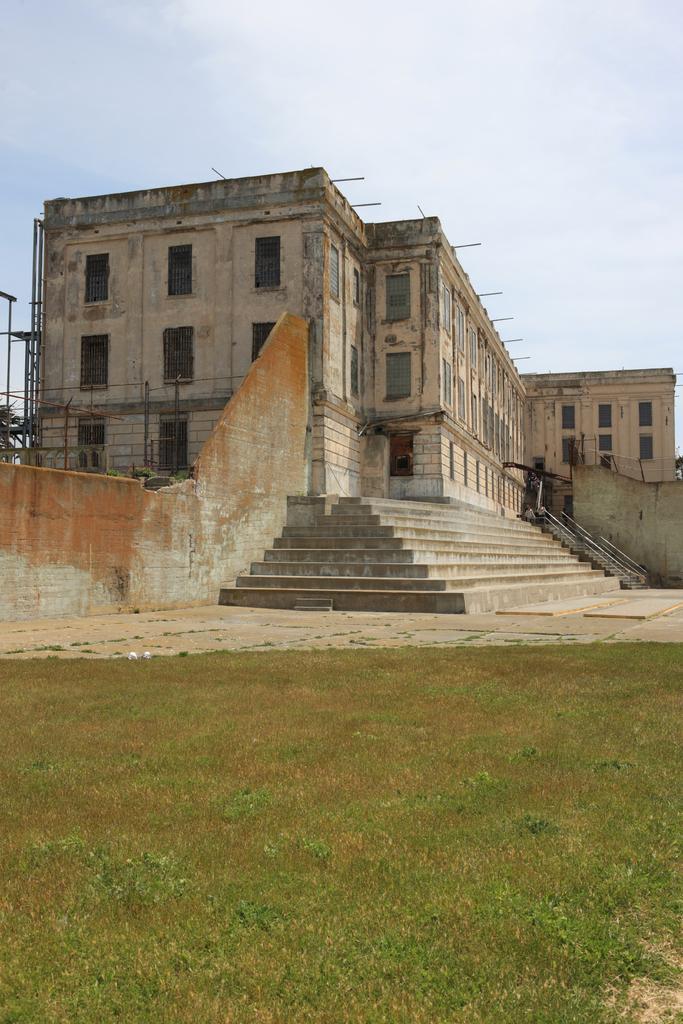Could you give a brief overview of what you see in this image? In this image we can see grass, steps, walls, and a building. In the background there is sky with clouds. 